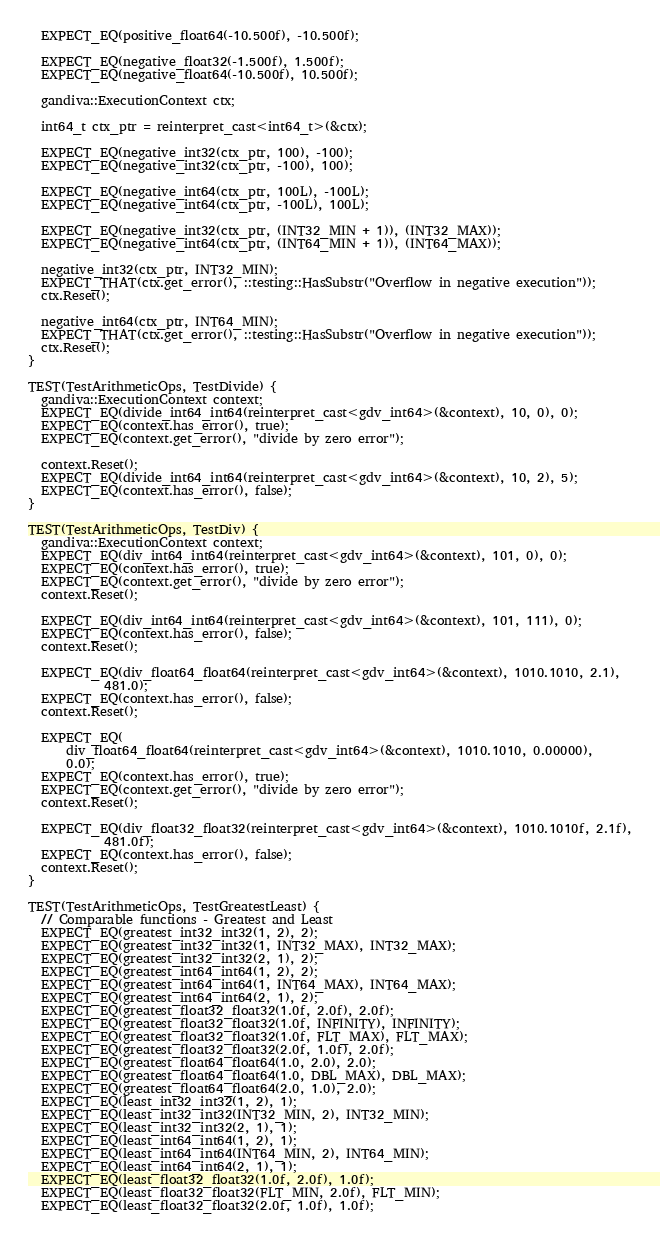<code> <loc_0><loc_0><loc_500><loc_500><_C++_>  EXPECT_EQ(positive_float64(-10.500f), -10.500f);

  EXPECT_EQ(negative_float32(-1.500f), 1.500f);
  EXPECT_EQ(negative_float64(-10.500f), 10.500f);

  gandiva::ExecutionContext ctx;

  int64_t ctx_ptr = reinterpret_cast<int64_t>(&ctx);

  EXPECT_EQ(negative_int32(ctx_ptr, 100), -100);
  EXPECT_EQ(negative_int32(ctx_ptr, -100), 100);

  EXPECT_EQ(negative_int64(ctx_ptr, 100L), -100L);
  EXPECT_EQ(negative_int64(ctx_ptr, -100L), 100L);

  EXPECT_EQ(negative_int32(ctx_ptr, (INT32_MIN + 1)), (INT32_MAX));
  EXPECT_EQ(negative_int64(ctx_ptr, (INT64_MIN + 1)), (INT64_MAX));

  negative_int32(ctx_ptr, INT32_MIN);
  EXPECT_THAT(ctx.get_error(), ::testing::HasSubstr("Overflow in negative execution"));
  ctx.Reset();

  negative_int64(ctx_ptr, INT64_MIN);
  EXPECT_THAT(ctx.get_error(), ::testing::HasSubstr("Overflow in negative execution"));
  ctx.Reset();
}

TEST(TestArithmeticOps, TestDivide) {
  gandiva::ExecutionContext context;
  EXPECT_EQ(divide_int64_int64(reinterpret_cast<gdv_int64>(&context), 10, 0), 0);
  EXPECT_EQ(context.has_error(), true);
  EXPECT_EQ(context.get_error(), "divide by zero error");

  context.Reset();
  EXPECT_EQ(divide_int64_int64(reinterpret_cast<gdv_int64>(&context), 10, 2), 5);
  EXPECT_EQ(context.has_error(), false);
}

TEST(TestArithmeticOps, TestDiv) {
  gandiva::ExecutionContext context;
  EXPECT_EQ(div_int64_int64(reinterpret_cast<gdv_int64>(&context), 101, 0), 0);
  EXPECT_EQ(context.has_error(), true);
  EXPECT_EQ(context.get_error(), "divide by zero error");
  context.Reset();

  EXPECT_EQ(div_int64_int64(reinterpret_cast<gdv_int64>(&context), 101, 111), 0);
  EXPECT_EQ(context.has_error(), false);
  context.Reset();

  EXPECT_EQ(div_float64_float64(reinterpret_cast<gdv_int64>(&context), 1010.1010, 2.1),
            481.0);
  EXPECT_EQ(context.has_error(), false);
  context.Reset();

  EXPECT_EQ(
      div_float64_float64(reinterpret_cast<gdv_int64>(&context), 1010.1010, 0.00000),
      0.0);
  EXPECT_EQ(context.has_error(), true);
  EXPECT_EQ(context.get_error(), "divide by zero error");
  context.Reset();

  EXPECT_EQ(div_float32_float32(reinterpret_cast<gdv_int64>(&context), 1010.1010f, 2.1f),
            481.0f);
  EXPECT_EQ(context.has_error(), false);
  context.Reset();
}

TEST(TestArithmeticOps, TestGreatestLeast) {
  // Comparable functions - Greatest and Least
  EXPECT_EQ(greatest_int32_int32(1, 2), 2);
  EXPECT_EQ(greatest_int32_int32(1, INT32_MAX), INT32_MAX);
  EXPECT_EQ(greatest_int32_int32(2, 1), 2);
  EXPECT_EQ(greatest_int64_int64(1, 2), 2);
  EXPECT_EQ(greatest_int64_int64(1, INT64_MAX), INT64_MAX);
  EXPECT_EQ(greatest_int64_int64(2, 1), 2);
  EXPECT_EQ(greatest_float32_float32(1.0f, 2.0f), 2.0f);
  EXPECT_EQ(greatest_float32_float32(1.0f, INFINITY), INFINITY);
  EXPECT_EQ(greatest_float32_float32(1.0f, FLT_MAX), FLT_MAX);
  EXPECT_EQ(greatest_float32_float32(2.0f, 1.0f), 2.0f);
  EXPECT_EQ(greatest_float64_float64(1.0, 2.0), 2.0);
  EXPECT_EQ(greatest_float64_float64(1.0, DBL_MAX), DBL_MAX);
  EXPECT_EQ(greatest_float64_float64(2.0, 1.0), 2.0);
  EXPECT_EQ(least_int32_int32(1, 2), 1);
  EXPECT_EQ(least_int32_int32(INT32_MIN, 2), INT32_MIN);
  EXPECT_EQ(least_int32_int32(2, 1), 1);
  EXPECT_EQ(least_int64_int64(1, 2), 1);
  EXPECT_EQ(least_int64_int64(INT64_MIN, 2), INT64_MIN);
  EXPECT_EQ(least_int64_int64(2, 1), 1);
  EXPECT_EQ(least_float32_float32(1.0f, 2.0f), 1.0f);
  EXPECT_EQ(least_float32_float32(FLT_MIN, 2.0f), FLT_MIN);
  EXPECT_EQ(least_float32_float32(2.0f, 1.0f), 1.0f);</code> 